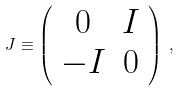<formula> <loc_0><loc_0><loc_500><loc_500>J \equiv \left ( \begin{array} { c c } 0 & I \\ - I & 0 \end{array} \right ) \, ,</formula> 